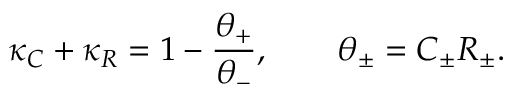<formula> <loc_0><loc_0><loc_500><loc_500>\kappa _ { C } + \kappa _ { R } = 1 - \frac { \theta _ { + } } { \theta _ { - } } , \quad \theta _ { \pm } = C _ { \pm } R _ { \pm } .</formula> 